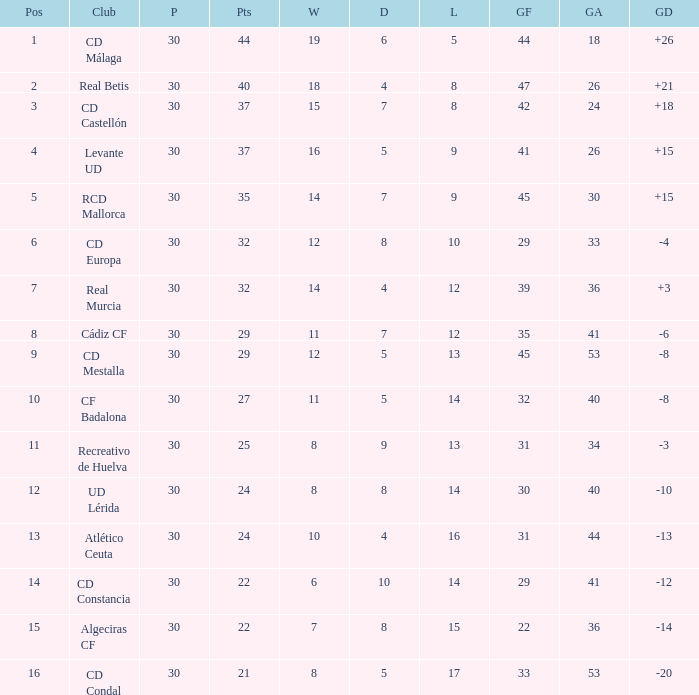What is the wins number when the points were smaller than 27, and goals against was 41? 6.0. 